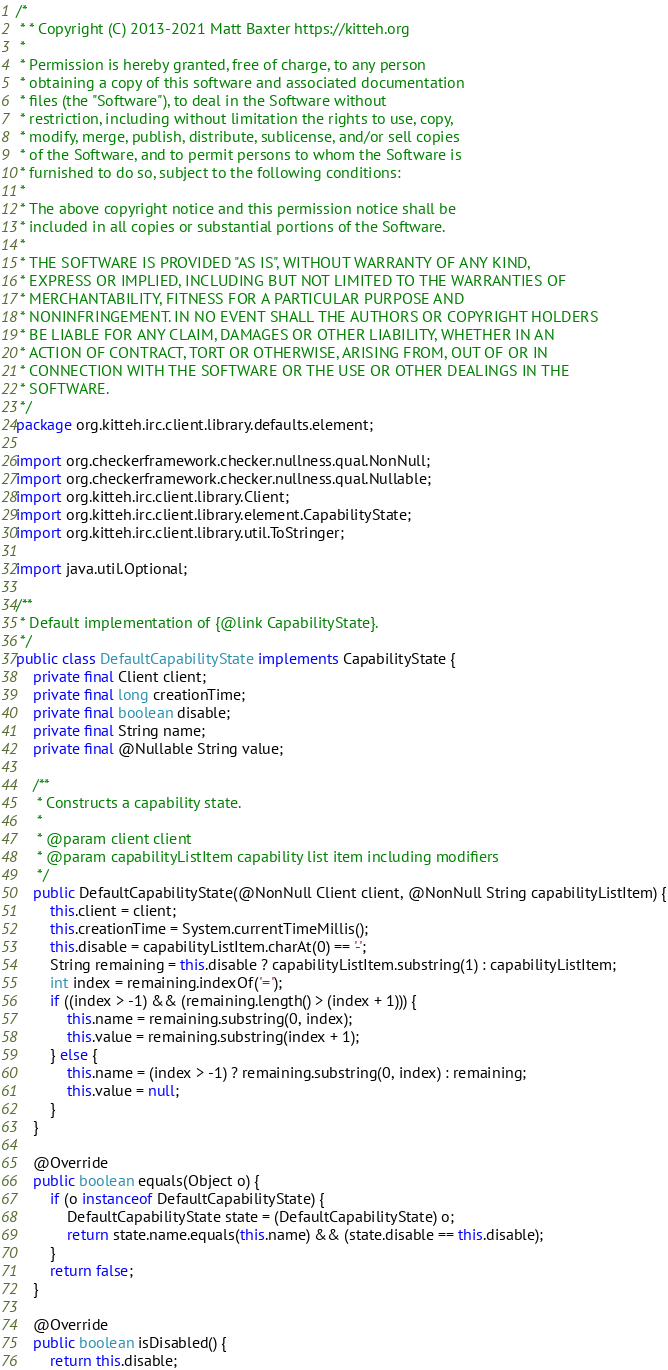Convert code to text. <code><loc_0><loc_0><loc_500><loc_500><_Java_>/*
 * * Copyright (C) 2013-2021 Matt Baxter https://kitteh.org
 *
 * Permission is hereby granted, free of charge, to any person
 * obtaining a copy of this software and associated documentation
 * files (the "Software"), to deal in the Software without
 * restriction, including without limitation the rights to use, copy,
 * modify, merge, publish, distribute, sublicense, and/or sell copies
 * of the Software, and to permit persons to whom the Software is
 * furnished to do so, subject to the following conditions:
 *
 * The above copyright notice and this permission notice shall be
 * included in all copies or substantial portions of the Software.
 *
 * THE SOFTWARE IS PROVIDED "AS IS", WITHOUT WARRANTY OF ANY KIND,
 * EXPRESS OR IMPLIED, INCLUDING BUT NOT LIMITED TO THE WARRANTIES OF
 * MERCHANTABILITY, FITNESS FOR A PARTICULAR PURPOSE AND
 * NONINFRINGEMENT. IN NO EVENT SHALL THE AUTHORS OR COPYRIGHT HOLDERS
 * BE LIABLE FOR ANY CLAIM, DAMAGES OR OTHER LIABILITY, WHETHER IN AN
 * ACTION OF CONTRACT, TORT OR OTHERWISE, ARISING FROM, OUT OF OR IN
 * CONNECTION WITH THE SOFTWARE OR THE USE OR OTHER DEALINGS IN THE
 * SOFTWARE.
 */
package org.kitteh.irc.client.library.defaults.element;

import org.checkerframework.checker.nullness.qual.NonNull;
import org.checkerframework.checker.nullness.qual.Nullable;
import org.kitteh.irc.client.library.Client;
import org.kitteh.irc.client.library.element.CapabilityState;
import org.kitteh.irc.client.library.util.ToStringer;

import java.util.Optional;

/**
 * Default implementation of {@link CapabilityState}.
 */
public class DefaultCapabilityState implements CapabilityState {
    private final Client client;
    private final long creationTime;
    private final boolean disable;
    private final String name;
    private final @Nullable String value;

    /**
     * Constructs a capability state.
     *
     * @param client client
     * @param capabilityListItem capability list item including modifiers
     */
    public DefaultCapabilityState(@NonNull Client client, @NonNull String capabilityListItem) {
        this.client = client;
        this.creationTime = System.currentTimeMillis();
        this.disable = capabilityListItem.charAt(0) == '-';
        String remaining = this.disable ? capabilityListItem.substring(1) : capabilityListItem;
        int index = remaining.indexOf('=');
        if ((index > -1) && (remaining.length() > (index + 1))) {
            this.name = remaining.substring(0, index);
            this.value = remaining.substring(index + 1);
        } else {
            this.name = (index > -1) ? remaining.substring(0, index) : remaining;
            this.value = null;
        }
    }

    @Override
    public boolean equals(Object o) {
        if (o instanceof DefaultCapabilityState) {
            DefaultCapabilityState state = (DefaultCapabilityState) o;
            return state.name.equals(this.name) && (state.disable == this.disable);
        }
        return false;
    }

    @Override
    public boolean isDisabled() {
        return this.disable;</code> 